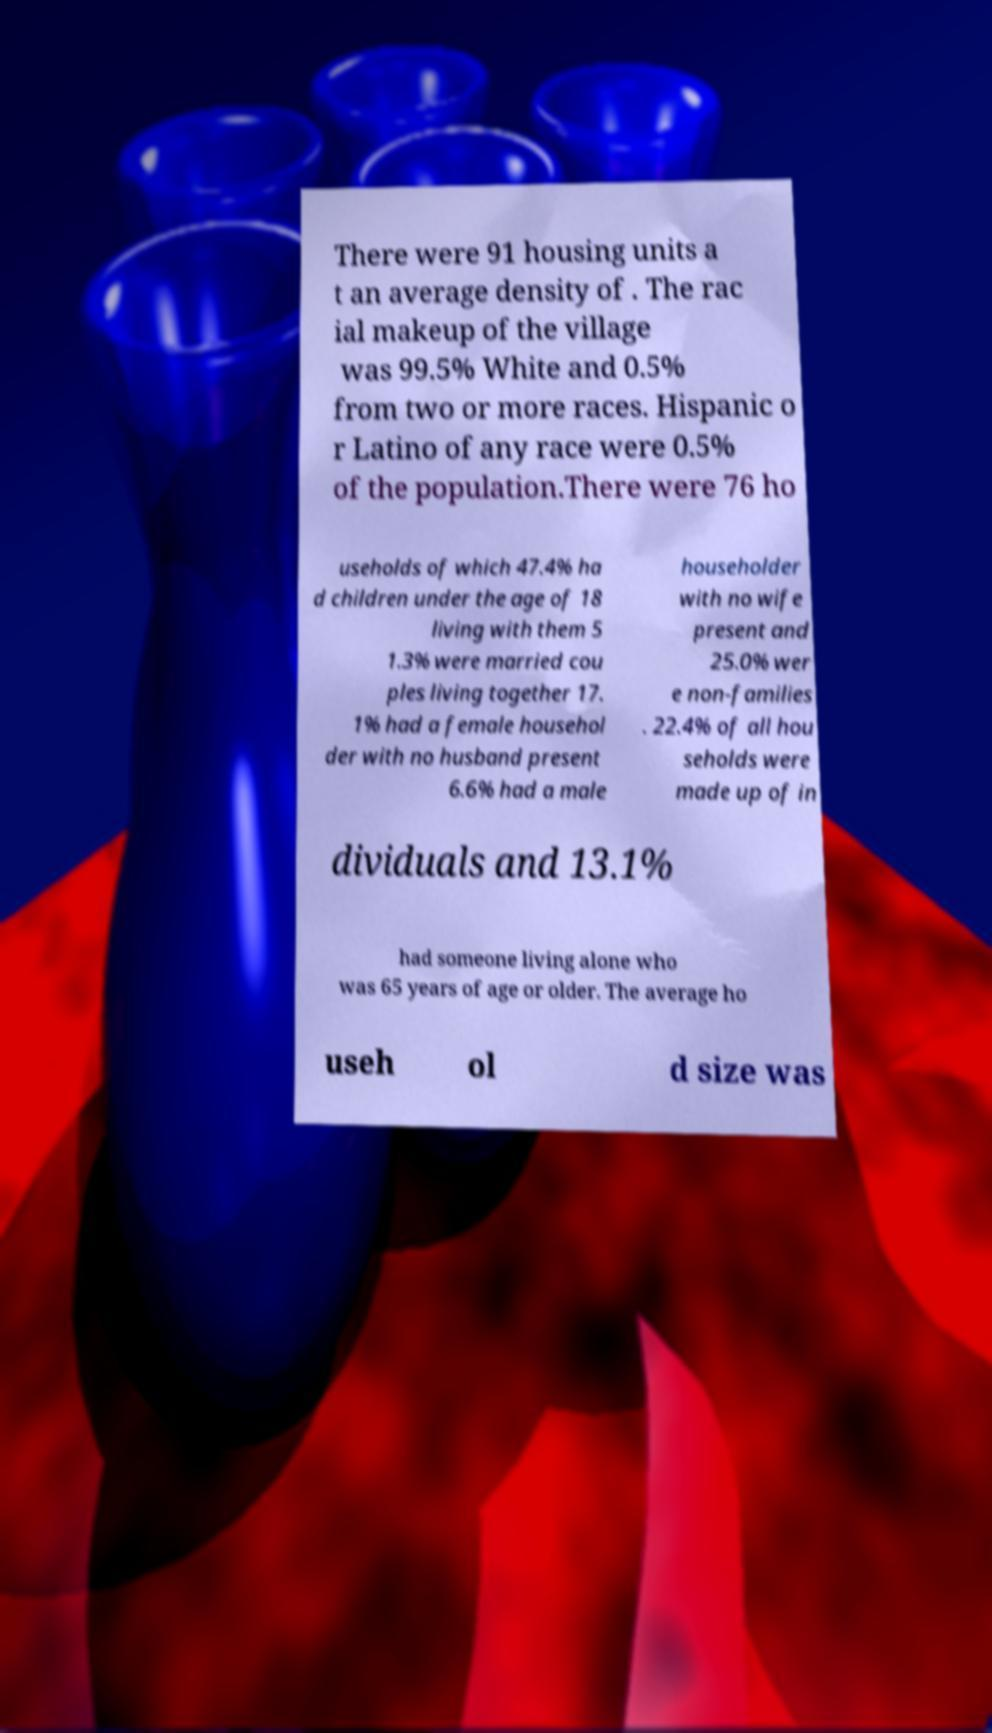Could you assist in decoding the text presented in this image and type it out clearly? There were 91 housing units a t an average density of . The rac ial makeup of the village was 99.5% White and 0.5% from two or more races. Hispanic o r Latino of any race were 0.5% of the population.There were 76 ho useholds of which 47.4% ha d children under the age of 18 living with them 5 1.3% were married cou ples living together 17. 1% had a female househol der with no husband present 6.6% had a male householder with no wife present and 25.0% wer e non-families . 22.4% of all hou seholds were made up of in dividuals and 13.1% had someone living alone who was 65 years of age or older. The average ho useh ol d size was 